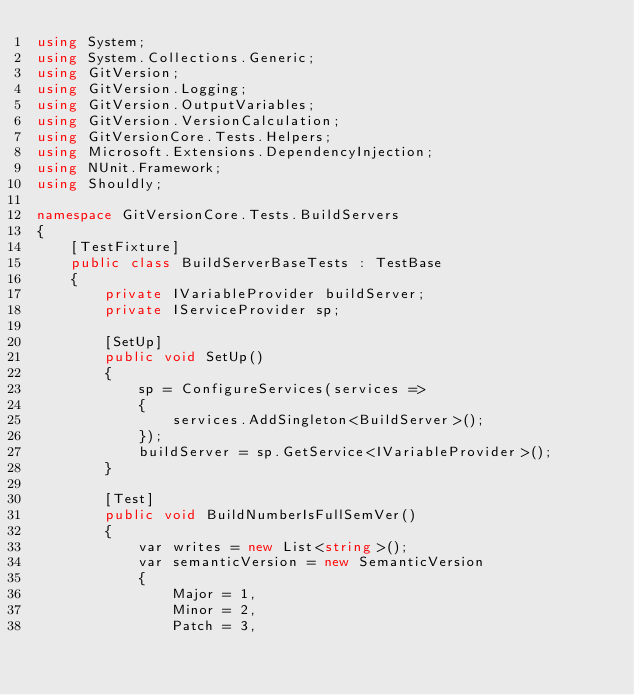<code> <loc_0><loc_0><loc_500><loc_500><_C#_>using System;
using System.Collections.Generic;
using GitVersion;
using GitVersion.Logging;
using GitVersion.OutputVariables;
using GitVersion.VersionCalculation;
using GitVersionCore.Tests.Helpers;
using Microsoft.Extensions.DependencyInjection;
using NUnit.Framework;
using Shouldly;

namespace GitVersionCore.Tests.BuildServers
{
    [TestFixture]
    public class BuildServerBaseTests : TestBase
    {
        private IVariableProvider buildServer;
        private IServiceProvider sp;

        [SetUp]
        public void SetUp()
        {
            sp = ConfigureServices(services =>
            {
                services.AddSingleton<BuildServer>();
            });
            buildServer = sp.GetService<IVariableProvider>();
        }

        [Test]
        public void BuildNumberIsFullSemVer()
        {
            var writes = new List<string>();
            var semanticVersion = new SemanticVersion
            {
                Major = 1,
                Minor = 2,
                Patch = 3,</code> 